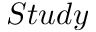<formula> <loc_0><loc_0><loc_500><loc_500>S t u d y</formula> 